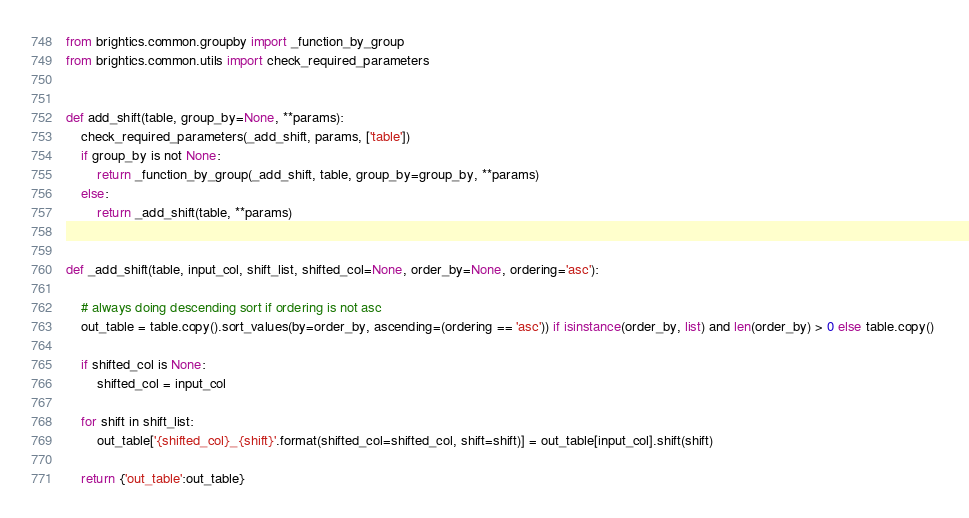<code> <loc_0><loc_0><loc_500><loc_500><_Python_>from brightics.common.groupby import _function_by_group
from brightics.common.utils import check_required_parameters


def add_shift(table, group_by=None, **params):
    check_required_parameters(_add_shift, params, ['table'])
    if group_by is not None:
        return _function_by_group(_add_shift, table, group_by=group_by, **params)
    else:
        return _add_shift(table, **params)

    
def _add_shift(table, input_col, shift_list, shifted_col=None, order_by=None, ordering='asc'):
     
    # always doing descending sort if ordering is not asc
    out_table = table.copy().sort_values(by=order_by, ascending=(ordering == 'asc')) if isinstance(order_by, list) and len(order_by) > 0 else table.copy() 
    
    if shifted_col is None:
        shifted_col = input_col
        
    for shift in shift_list:
        out_table['{shifted_col}_{shift}'.format(shifted_col=shifted_col, shift=shift)] = out_table[input_col].shift(shift)
        
    return {'out_table':out_table}
</code> 